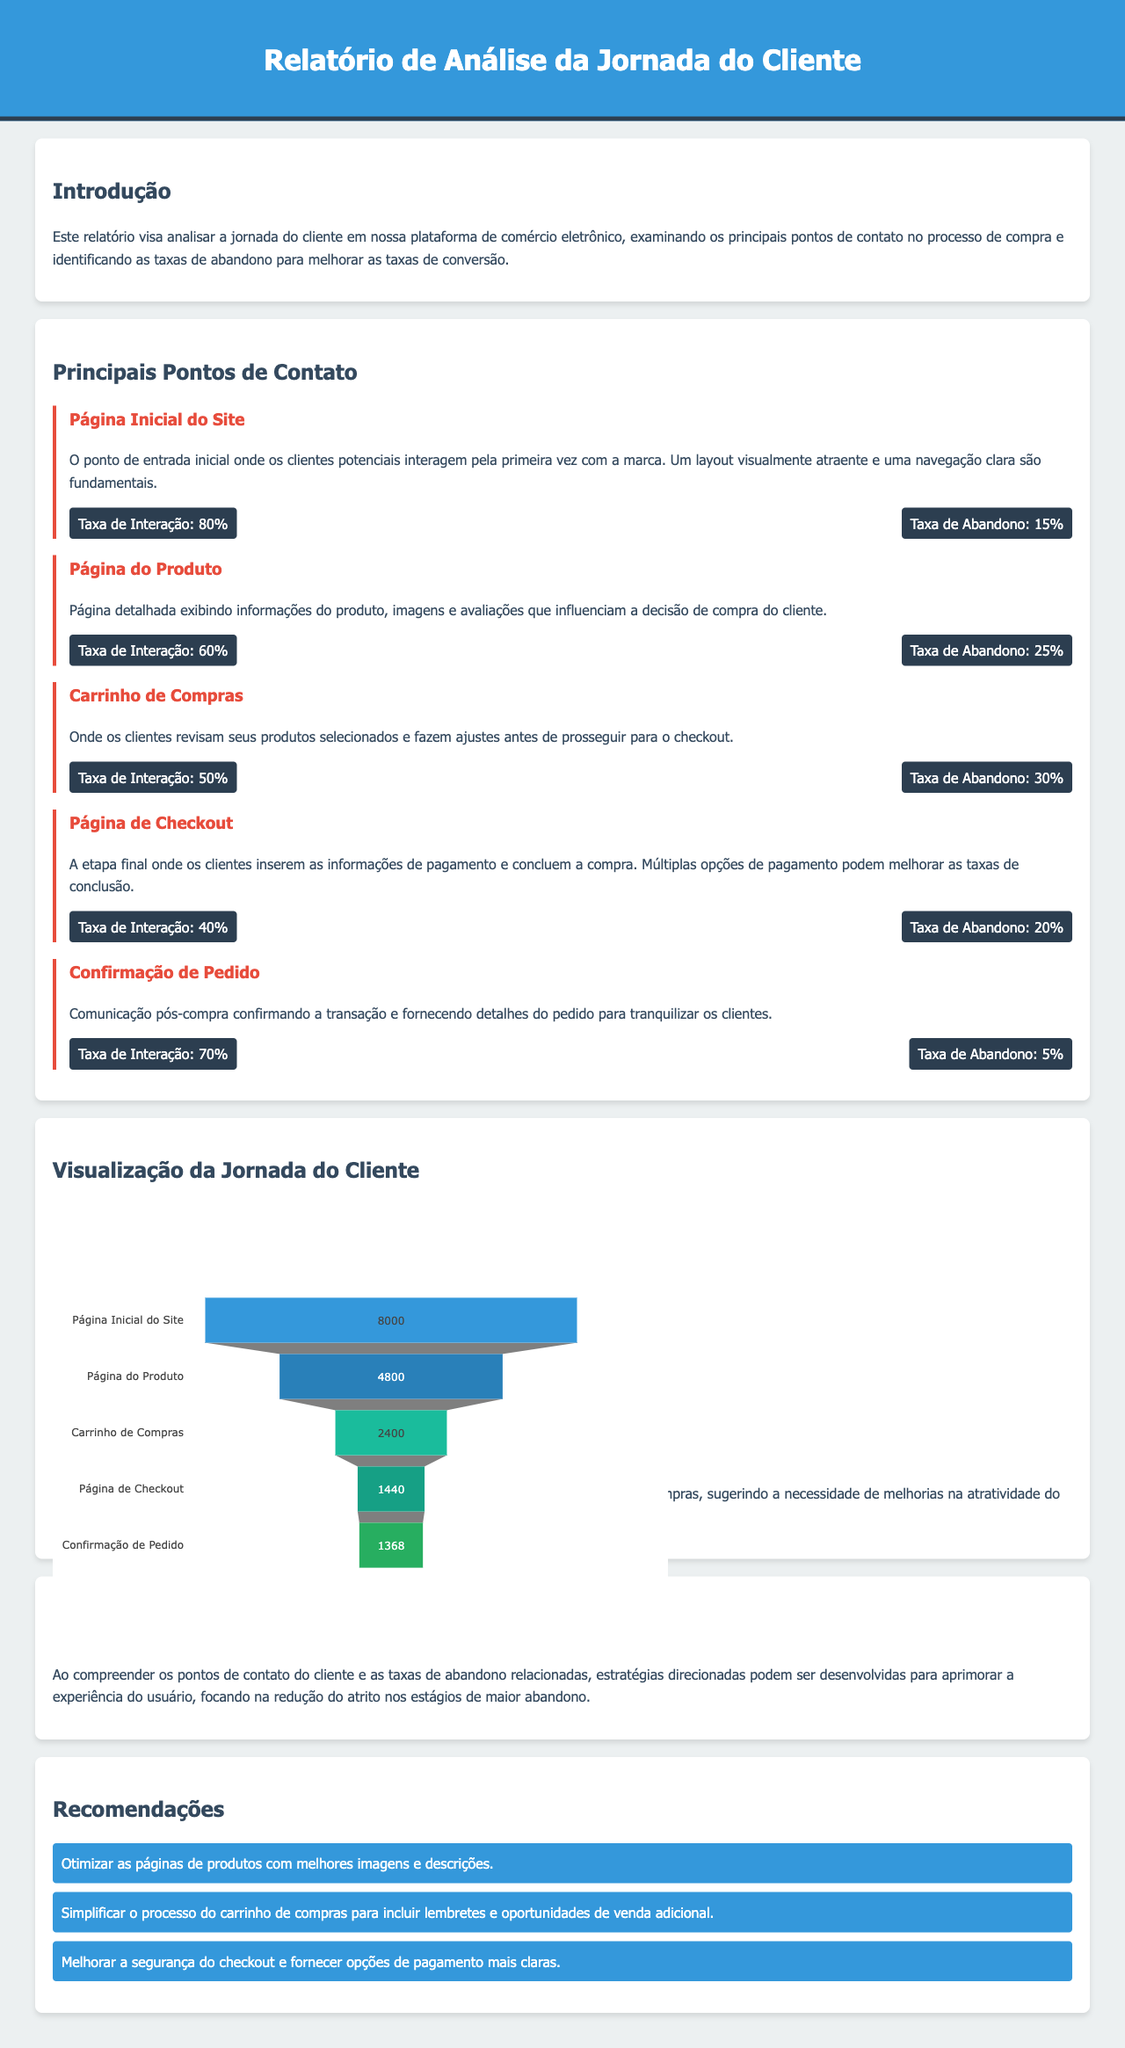Qual é a taxa de interação na Página Inicial do Site? A taxa de interação na Página Inicial do Site é apresentada em uma seção específica do relatório, que é 80%.
Answer: 80% Qual ponto de contato tem a maior taxa de abandono? Ao comparar as taxas de abandono em cada ponto de contato, a Página do Produto apresenta a maior taxa de abandono com 25%.
Answer: 25% Quantos produtos são considerados na visualização do funil? O número de produtos considerado é mencionado nos pontos de contato do funil, totalizando 5.
Answer: 5 Qual é a taxa de interatividade na Página de Checkout? A taxa de interatividade dada na seção de estatísticas para a Página de Checkout é de 40%.
Answer: 40% Quais são as recomendações para otimizar a experiência do usuário? Na seção de recomendações, são listadas três sugestões para aprimorar a experiência do usuário.
Answer: Otimizar imagens, simplificar carrinho, melhorar segurança do checkout Qual foi a taxa de abandono na confirmação de pedido? A taxa de abandono na confirmação de pedido é especificada como 5% na respectiva seção do relatório.
Answer: 5% Qual a taxa de abandono do Carrinho de Compras? A taxa de abandono do Carrinho de Compras é detalhada como 30% no contexto do relatório.
Answer: 30% Quantos clientes interagiram na Página do Produto? A quantidade de interações na Página do Produto é dada como 4800 interações no gráfico do funil.
Answer: 4800 Qual insight é destacado sobre a jornada do cliente? Um insight importante é que há uma queda significativa entre a Página do Produto e o Carrinho de Compras.
Answer: Queda significativa entre Página do Produto e Carrinho de Compras 